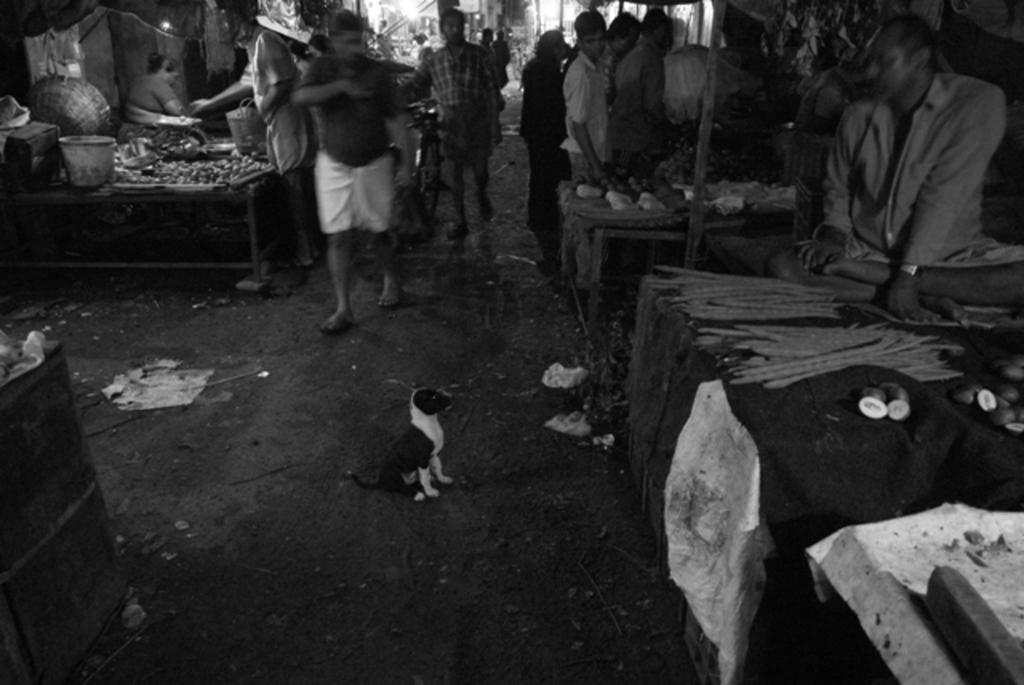What is the main subject in the middle of the image? There is a dog in the middle of the image. What are the people behind the dog doing? The people are standing behind the dog and holding bicycles. What can be seen on the tables in the image? There are vegetables on the tables. How many tables are visible in the image? The provided facts do not specify the number of tables, so we cannot definitively answer this question. What type of quill is the dog using to write on the vegetables in the image? There is no quill present in the image, and the dog is not writing on the vegetables. 